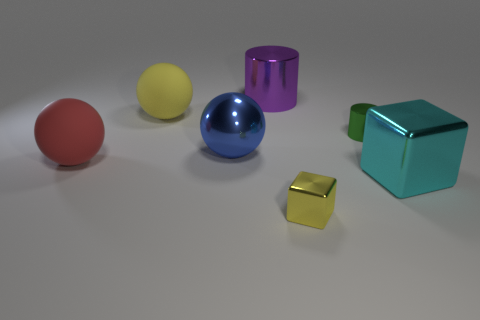Subtract all big blue metallic spheres. How many spheres are left? 2 Subtract all balls. How many objects are left? 4 Subtract all yellow balls. How many balls are left? 2 Subtract 1 balls. How many balls are left? 2 Add 1 yellow things. How many objects exist? 8 Subtract 0 gray cubes. How many objects are left? 7 Subtract all yellow blocks. Subtract all brown cylinders. How many blocks are left? 1 Subtract all blocks. Subtract all matte objects. How many objects are left? 3 Add 5 large metallic things. How many large metallic things are left? 8 Add 3 metallic cylinders. How many metallic cylinders exist? 5 